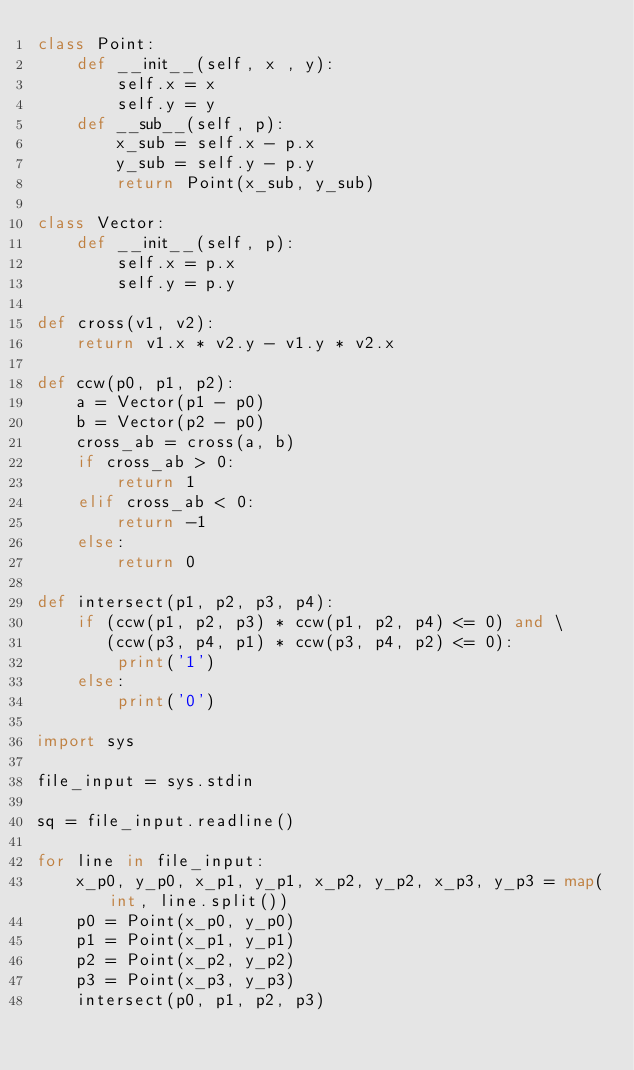<code> <loc_0><loc_0><loc_500><loc_500><_Python_>class Point:
    def __init__(self, x , y):
        self.x = x
        self.y = y
    def __sub__(self, p):
        x_sub = self.x - p.x
        y_sub = self.y - p.y
        return Point(x_sub, y_sub)

class Vector:
    def __init__(self, p):
        self.x = p.x
        self.y = p.y

def cross(v1, v2):
    return v1.x * v2.y - v1.y * v2.x

def ccw(p0, p1, p2):
    a = Vector(p1 - p0)
    b = Vector(p2 - p0)
    cross_ab = cross(a, b)
    if cross_ab > 0:
        return 1
    elif cross_ab < 0:
        return -1
    else:
        return 0

def intersect(p1, p2, p3, p4):
    if (ccw(p1, p2, p3) * ccw(p1, p2, p4) <= 0) and \
       (ccw(p3, p4, p1) * ccw(p3, p4, p2) <= 0):
        print('1')
    else:
        print('0')

import sys

file_input = sys.stdin

sq = file_input.readline()

for line in file_input:
    x_p0, y_p0, x_p1, y_p1, x_p2, y_p2, x_p3, y_p3 = map(int, line.split())
    p0 = Point(x_p0, y_p0)
    p1 = Point(x_p1, y_p1)
    p2 = Point(x_p2, y_p2)
    p3 = Point(x_p3, y_p3)
    intersect(p0, p1, p2, p3)</code> 